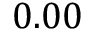Convert formula to latex. <formula><loc_0><loc_0><loc_500><loc_500>0 . 0 0</formula> 